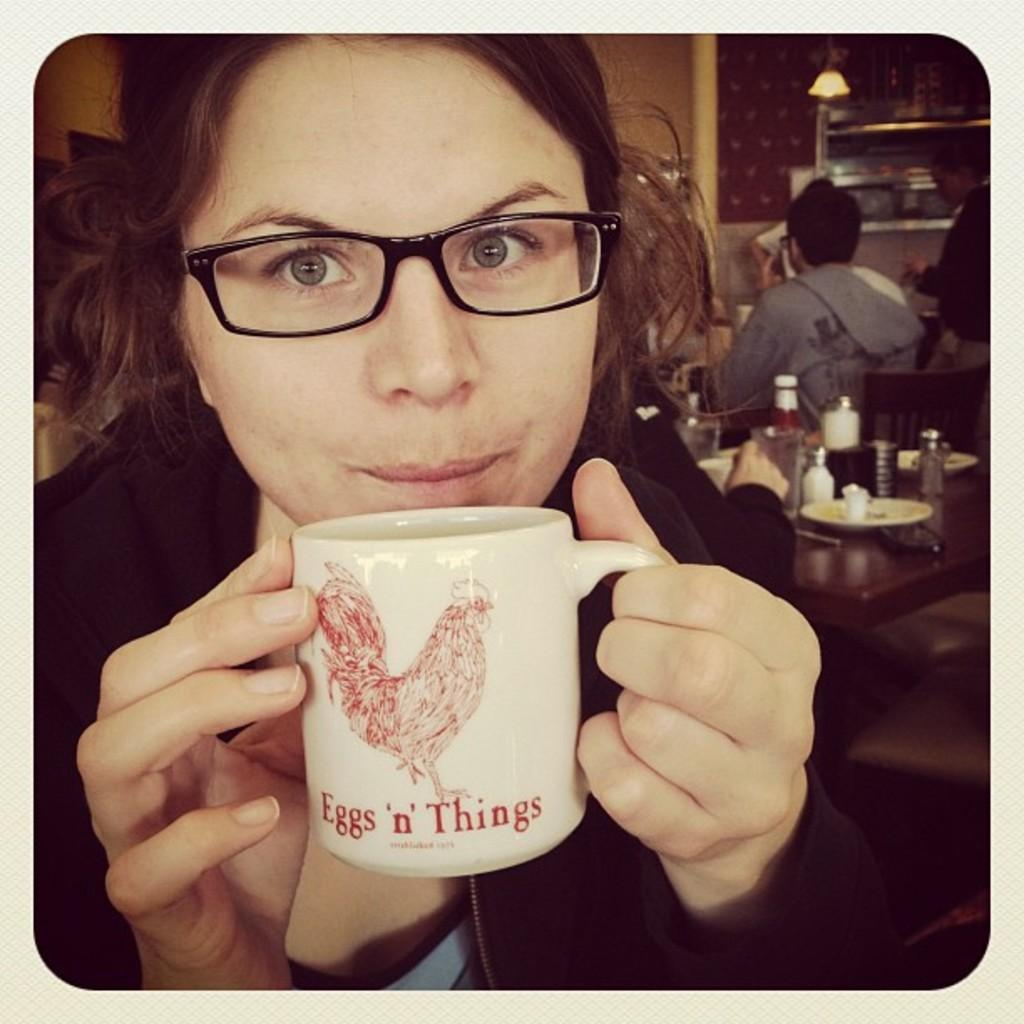<image>
Provide a brief description of the given image. A woman sips coffee from an Eggs & Things coffee mug. 